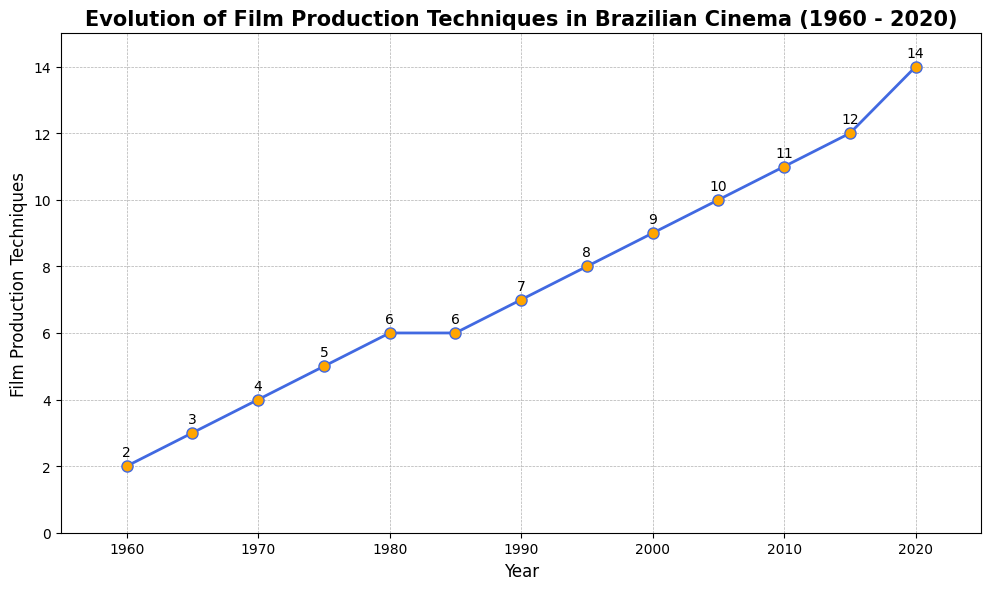How many film production techniques were added between 1960 and 1980? To determine how many film production techniques were added between 1960 and 1980, we need to subtract the number of techniques in 1960 from the number in 1980. In 1960 there were 2 techniques, and in 1980 there were 6. Therefore,  6 - 2 = 4.
Answer: 4 Which year had the most significant increase in film production techniques compared to the previous five years? By examining the chart, we look for the year with the highest increase compared to 5 years earlier. From the data, 2020 had the steepest rise compared to 2015 (14 - 12 = 2), but compared to the previous five years, 1985 stood out (6 - 5 = 1 over 5 years, which is the highest).
Answer: 1985 Which two consecutive years had the largest increase in the number of film production techniques? To determine the two consecutive years with the largest increase, we need to examine the gaps between each pair of consecutive years. The biggest increase was from 2015 to 2020, which was 14 - 12 = 2.
Answer: 2015 to 2020 Was there any period where the number of film production techniques remained the same? To find this, we look for flat sections in the chart. From 1980 to 1985, the number of techniques stayed constant at 6.
Answer: Yes, from 1980 to 1985 What is the average number of film production techniques used in Brazilian cinema from 1970 to 2000? To calculate the average, sum the number of techniques for 1970, 1975, 1980, 1985, 1990, 1995, and 2000 and divide by the number of years. (4 + 5 + 6 + 6 + 7 + 8 + 9) / 7 = 6.4286.
Answer: 6.4286 Comparing the years 1965 and 2010, how much has the number of film production techniques increased? To find the increase, we subtract the number of techniques in 1965 from that in 2010. There were 3 techniques in 1965 and 11 in 2010. So, 11 - 3 = 8.
Answer: 8 Around what year did the number of techniques start to significantly rise after a period of stability? Identifying the year from the chart, we see that the period of stability was around 1980 to 1985, after which there was a rise. Therefore, around 1990 saw the start of a significant rise.
Answer: Around 1990 How has the trend evolved from 1990 to 2020? By observing the graph from 1990 to 2020, we see a steady increase from 7 techniques to 14, indicating continuous growth.
Answer: Continuous growth By what percentage did the number of film production techniques increase from 1960 to 2020? Calculate the percentage increase using the formula [(Final - Initial) / Initial] * 100. For the years 1960 and 2020: [(14 - 2) / 2] * 100 = 600%.
Answer: 600% What visual elements highlight the change in film technologies over time? The color "royalblue" for the line, orange markers, and grid lines emphasize the trends and individual data points, showing a clear visual progression over time.
Answer: Line color, marker color, grid lines 